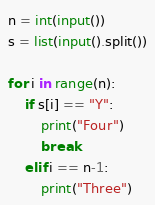Convert code to text. <code><loc_0><loc_0><loc_500><loc_500><_Python_>n = int(input())
s = list(input().split())

for i in range(n):
    if s[i] == "Y":
        print("Four")
        break
    elif i == n-1:
        print("Three")
</code> 